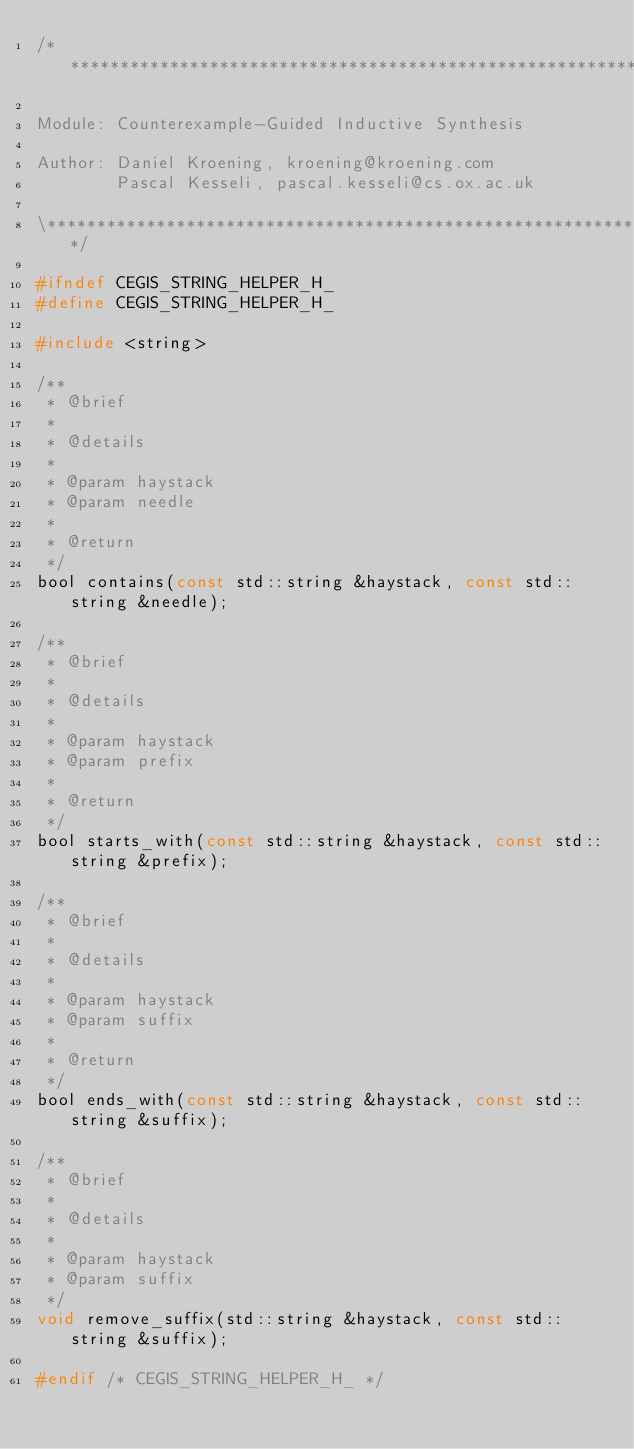Convert code to text. <code><loc_0><loc_0><loc_500><loc_500><_C_>/*******************************************************************

Module: Counterexample-Guided Inductive Synthesis

Author: Daniel Kroening, kroening@kroening.com
        Pascal Kesseli, pascal.kesseli@cs.ox.ac.uk

\*******************************************************************/

#ifndef CEGIS_STRING_HELPER_H_
#define CEGIS_STRING_HELPER_H_

#include <string>

/**
 * @brief
 *
 * @details
 *
 * @param haystack
 * @param needle
 *
 * @return
 */
bool contains(const std::string &haystack, const std::string &needle);

/**
 * @brief
 *
 * @details
 *
 * @param haystack
 * @param prefix
 *
 * @return
 */
bool starts_with(const std::string &haystack, const std::string &prefix);

/**
 * @brief
 *
 * @details
 *
 * @param haystack
 * @param suffix
 *
 * @return
 */
bool ends_with(const std::string &haystack, const std::string &suffix);

/**
 * @brief
 *
 * @details
 *
 * @param haystack
 * @param suffix
 */
void remove_suffix(std::string &haystack, const std::string &suffix);

#endif /* CEGIS_STRING_HELPER_H_ */
</code> 